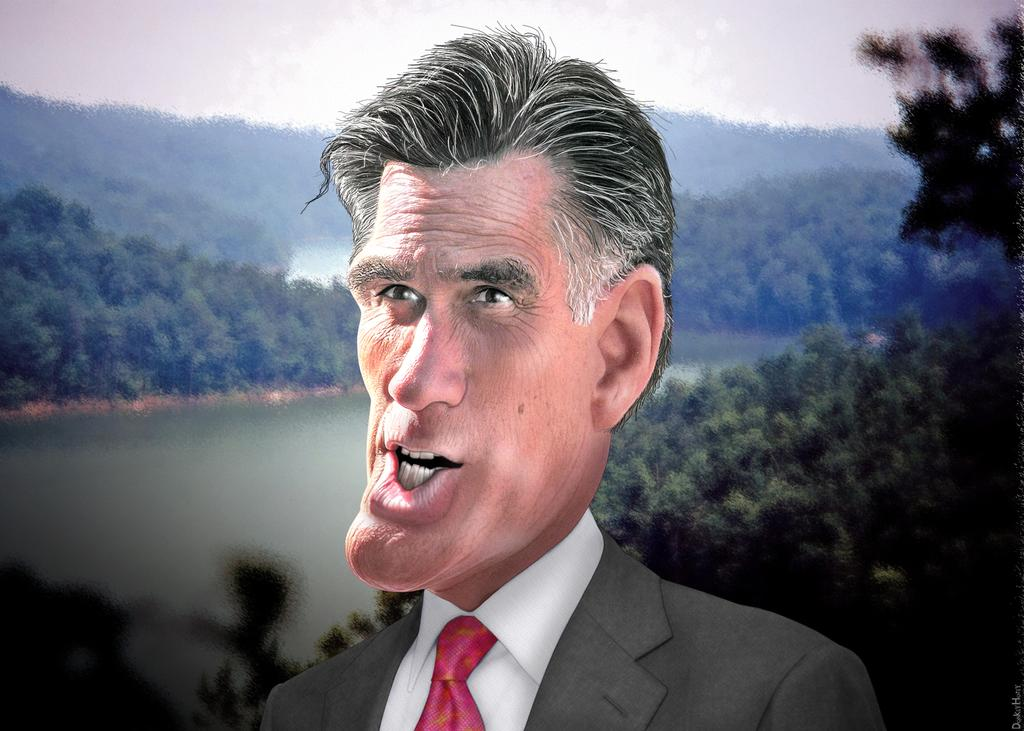Who or what is present in the image? There is a person in the image. What is the person wearing? The person is wearing a suit. What can be seen in the background of the image? There are trees and water visible in the background of the image. What type of paper is the person holding in the image? There is no paper visible in the image; the person is not holding anything. 